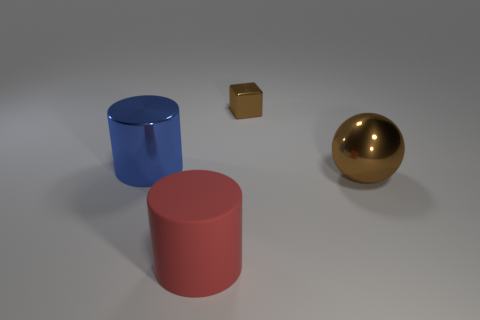What number of red rubber cubes are there?
Keep it short and to the point. 0. Is there a large thing that has the same material as the brown cube?
Your response must be concise. Yes. There is another object that is the same color as the small shiny thing; what size is it?
Ensure brevity in your answer.  Large. Do the thing on the right side of the small brown block and the brown thing that is behind the brown ball have the same size?
Your answer should be compact. No. There is a cylinder that is in front of the large sphere; what is its size?
Offer a terse response. Large. Is there a large metal sphere of the same color as the metal cube?
Your response must be concise. Yes. There is a thing that is right of the small thing; are there any big brown metal spheres that are to the left of it?
Your response must be concise. No. Is the size of the blue metallic cylinder the same as the cylinder that is right of the big blue object?
Make the answer very short. Yes. There is a shiny object behind the cylinder that is left of the large red matte object; is there a large brown thing to the right of it?
Offer a very short reply. Yes. There is a big thing to the right of the small metallic block; what material is it?
Provide a short and direct response. Metal. 